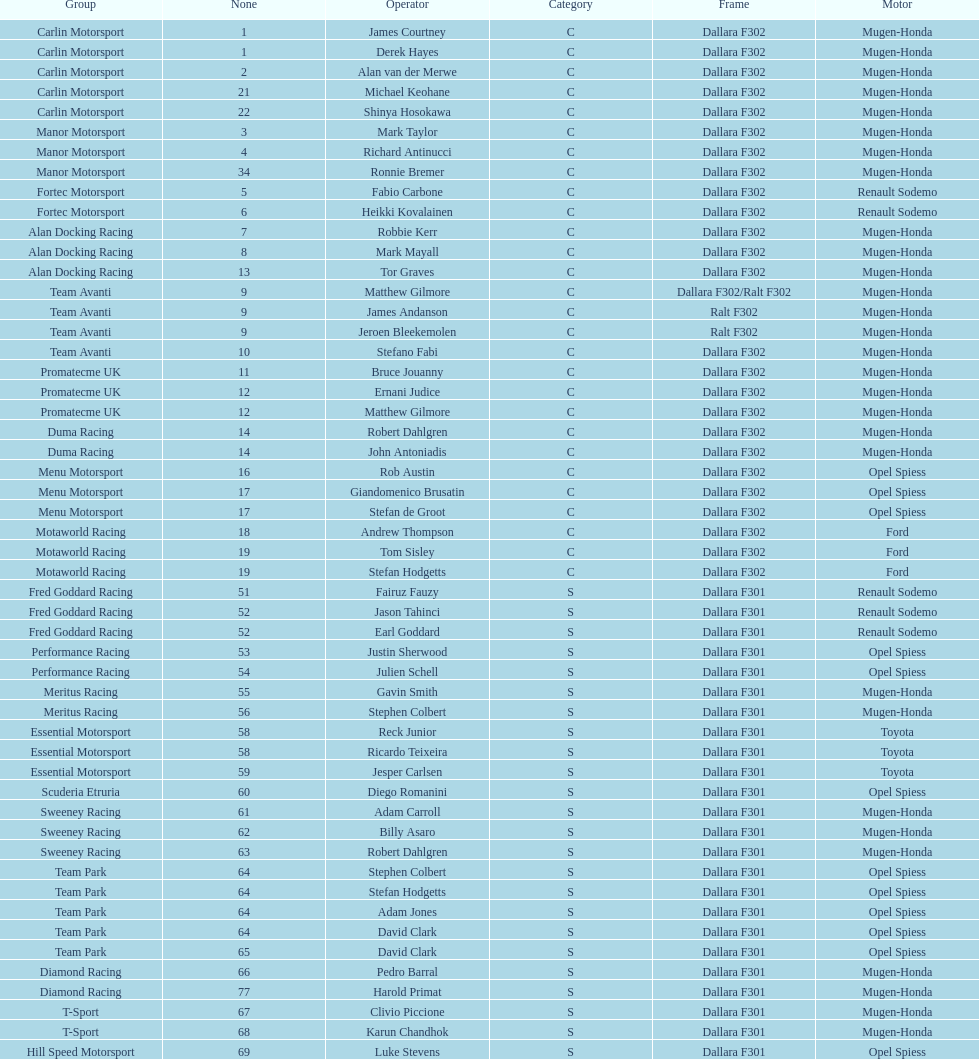Could you parse the entire table? {'header': ['Group', 'None', 'Operator', 'Category', 'Frame', 'Motor'], 'rows': [['Carlin Motorsport', '1', 'James Courtney', 'C', 'Dallara F302', 'Mugen-Honda'], ['Carlin Motorsport', '1', 'Derek Hayes', 'C', 'Dallara F302', 'Mugen-Honda'], ['Carlin Motorsport', '2', 'Alan van der Merwe', 'C', 'Dallara F302', 'Mugen-Honda'], ['Carlin Motorsport', '21', 'Michael Keohane', 'C', 'Dallara F302', 'Mugen-Honda'], ['Carlin Motorsport', '22', 'Shinya Hosokawa', 'C', 'Dallara F302', 'Mugen-Honda'], ['Manor Motorsport', '3', 'Mark Taylor', 'C', 'Dallara F302', 'Mugen-Honda'], ['Manor Motorsport', '4', 'Richard Antinucci', 'C', 'Dallara F302', 'Mugen-Honda'], ['Manor Motorsport', '34', 'Ronnie Bremer', 'C', 'Dallara F302', 'Mugen-Honda'], ['Fortec Motorsport', '5', 'Fabio Carbone', 'C', 'Dallara F302', 'Renault Sodemo'], ['Fortec Motorsport', '6', 'Heikki Kovalainen', 'C', 'Dallara F302', 'Renault Sodemo'], ['Alan Docking Racing', '7', 'Robbie Kerr', 'C', 'Dallara F302', 'Mugen-Honda'], ['Alan Docking Racing', '8', 'Mark Mayall', 'C', 'Dallara F302', 'Mugen-Honda'], ['Alan Docking Racing', '13', 'Tor Graves', 'C', 'Dallara F302', 'Mugen-Honda'], ['Team Avanti', '9', 'Matthew Gilmore', 'C', 'Dallara F302/Ralt F302', 'Mugen-Honda'], ['Team Avanti', '9', 'James Andanson', 'C', 'Ralt F302', 'Mugen-Honda'], ['Team Avanti', '9', 'Jeroen Bleekemolen', 'C', 'Ralt F302', 'Mugen-Honda'], ['Team Avanti', '10', 'Stefano Fabi', 'C', 'Dallara F302', 'Mugen-Honda'], ['Promatecme UK', '11', 'Bruce Jouanny', 'C', 'Dallara F302', 'Mugen-Honda'], ['Promatecme UK', '12', 'Ernani Judice', 'C', 'Dallara F302', 'Mugen-Honda'], ['Promatecme UK', '12', 'Matthew Gilmore', 'C', 'Dallara F302', 'Mugen-Honda'], ['Duma Racing', '14', 'Robert Dahlgren', 'C', 'Dallara F302', 'Mugen-Honda'], ['Duma Racing', '14', 'John Antoniadis', 'C', 'Dallara F302', 'Mugen-Honda'], ['Menu Motorsport', '16', 'Rob Austin', 'C', 'Dallara F302', 'Opel Spiess'], ['Menu Motorsport', '17', 'Giandomenico Brusatin', 'C', 'Dallara F302', 'Opel Spiess'], ['Menu Motorsport', '17', 'Stefan de Groot', 'C', 'Dallara F302', 'Opel Spiess'], ['Motaworld Racing', '18', 'Andrew Thompson', 'C', 'Dallara F302', 'Ford'], ['Motaworld Racing', '19', 'Tom Sisley', 'C', 'Dallara F302', 'Ford'], ['Motaworld Racing', '19', 'Stefan Hodgetts', 'C', 'Dallara F302', 'Ford'], ['Fred Goddard Racing', '51', 'Fairuz Fauzy', 'S', 'Dallara F301', 'Renault Sodemo'], ['Fred Goddard Racing', '52', 'Jason Tahinci', 'S', 'Dallara F301', 'Renault Sodemo'], ['Fred Goddard Racing', '52', 'Earl Goddard', 'S', 'Dallara F301', 'Renault Sodemo'], ['Performance Racing', '53', 'Justin Sherwood', 'S', 'Dallara F301', 'Opel Spiess'], ['Performance Racing', '54', 'Julien Schell', 'S', 'Dallara F301', 'Opel Spiess'], ['Meritus Racing', '55', 'Gavin Smith', 'S', 'Dallara F301', 'Mugen-Honda'], ['Meritus Racing', '56', 'Stephen Colbert', 'S', 'Dallara F301', 'Mugen-Honda'], ['Essential Motorsport', '58', 'Reck Junior', 'S', 'Dallara F301', 'Toyota'], ['Essential Motorsport', '58', 'Ricardo Teixeira', 'S', 'Dallara F301', 'Toyota'], ['Essential Motorsport', '59', 'Jesper Carlsen', 'S', 'Dallara F301', 'Toyota'], ['Scuderia Etruria', '60', 'Diego Romanini', 'S', 'Dallara F301', 'Opel Spiess'], ['Sweeney Racing', '61', 'Adam Carroll', 'S', 'Dallara F301', 'Mugen-Honda'], ['Sweeney Racing', '62', 'Billy Asaro', 'S', 'Dallara F301', 'Mugen-Honda'], ['Sweeney Racing', '63', 'Robert Dahlgren', 'S', 'Dallara F301', 'Mugen-Honda'], ['Team Park', '64', 'Stephen Colbert', 'S', 'Dallara F301', 'Opel Spiess'], ['Team Park', '64', 'Stefan Hodgetts', 'S', 'Dallara F301', 'Opel Spiess'], ['Team Park', '64', 'Adam Jones', 'S', 'Dallara F301', 'Opel Spiess'], ['Team Park', '64', 'David Clark', 'S', 'Dallara F301', 'Opel Spiess'], ['Team Park', '65', 'David Clark', 'S', 'Dallara F301', 'Opel Spiess'], ['Diamond Racing', '66', 'Pedro Barral', 'S', 'Dallara F301', 'Mugen-Honda'], ['Diamond Racing', '77', 'Harold Primat', 'S', 'Dallara F301', 'Mugen-Honda'], ['T-Sport', '67', 'Clivio Piccione', 'S', 'Dallara F301', 'Mugen-Honda'], ['T-Sport', '68', 'Karun Chandhok', 'S', 'Dallara F301', 'Mugen-Honda'], ['Hill Speed Motorsport', '69', 'Luke Stevens', 'S', 'Dallara F301', 'Opel Spiess']]} What is the average number of teams that had a mugen-honda engine? 24. 